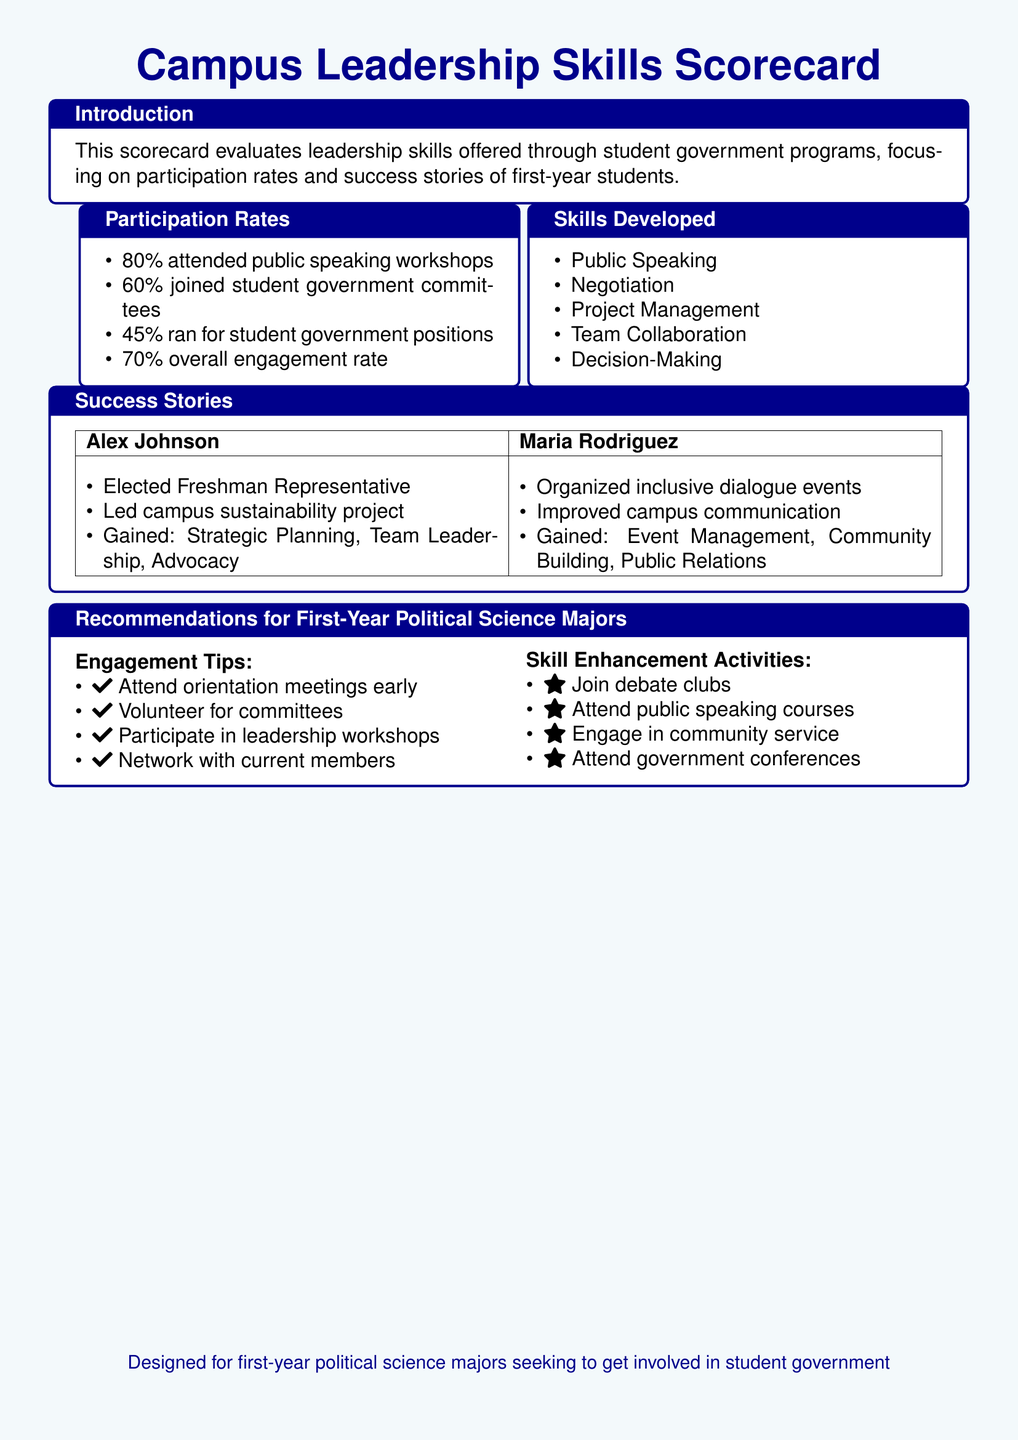What percentage of first-year students attended public speaking workshops? The document states that 80% of students attended public speaking workshops, which is a specific participation rate.
Answer: 80% What skill is listed under 'Skills Developed'? The document includes a list of skills developed, and one of them is Public Speaking.
Answer: Public Speaking Who is mentioned as having organized inclusive dialogue events? The document lists success stories and mentions Maria Rodriguez for organizing inclusive dialogue events.
Answer: Maria Rodriguez What is the overall engagement rate of first-year students in student government programs? A specific participation statistic is given in the document, which is the overall engagement rate of 70%.
Answer: 70% What recommendation is given for first-year political science majors regarding workshops? The document recommends participating in leadership workshops for first-year students.
Answer: Participate in leadership workshops How many skills are listed under 'Skills Developed'? The document provides a list of skills, and there are five skills mentioned.
Answer: Five What specific achievement is associated with Alex Johnson? The document notes that Alex Johnson was elected as Freshman Representative, which is a specific success story.
Answer: Elected Freshman Representative Which activities are recommended for skill enhancement? The document lists four activities for skill enhancement, including joining debate clubs.
Answer: Join debate clubs How many first-year students ran for student government positions? The document indicates that 45% of first-year students ran for positions in student government.
Answer: 45% 